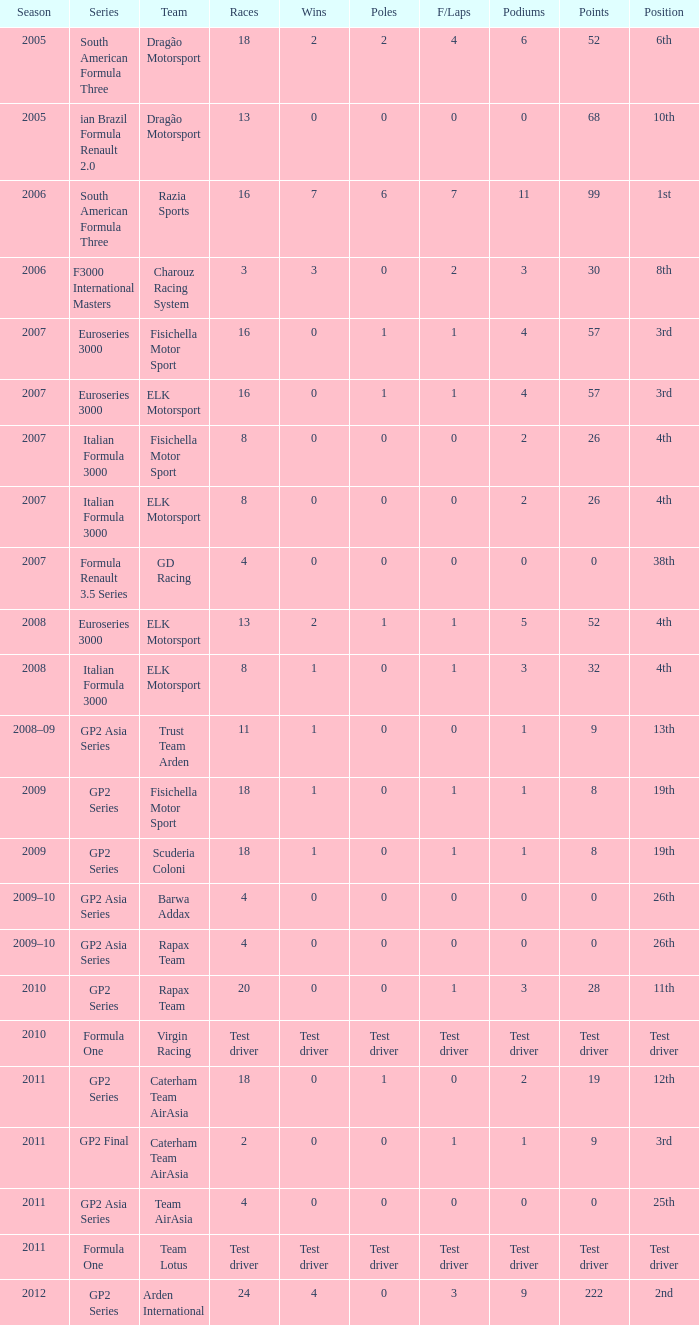In which season did he have 0 Poles and 19th position in the GP2 Series? 2009, 2009. 